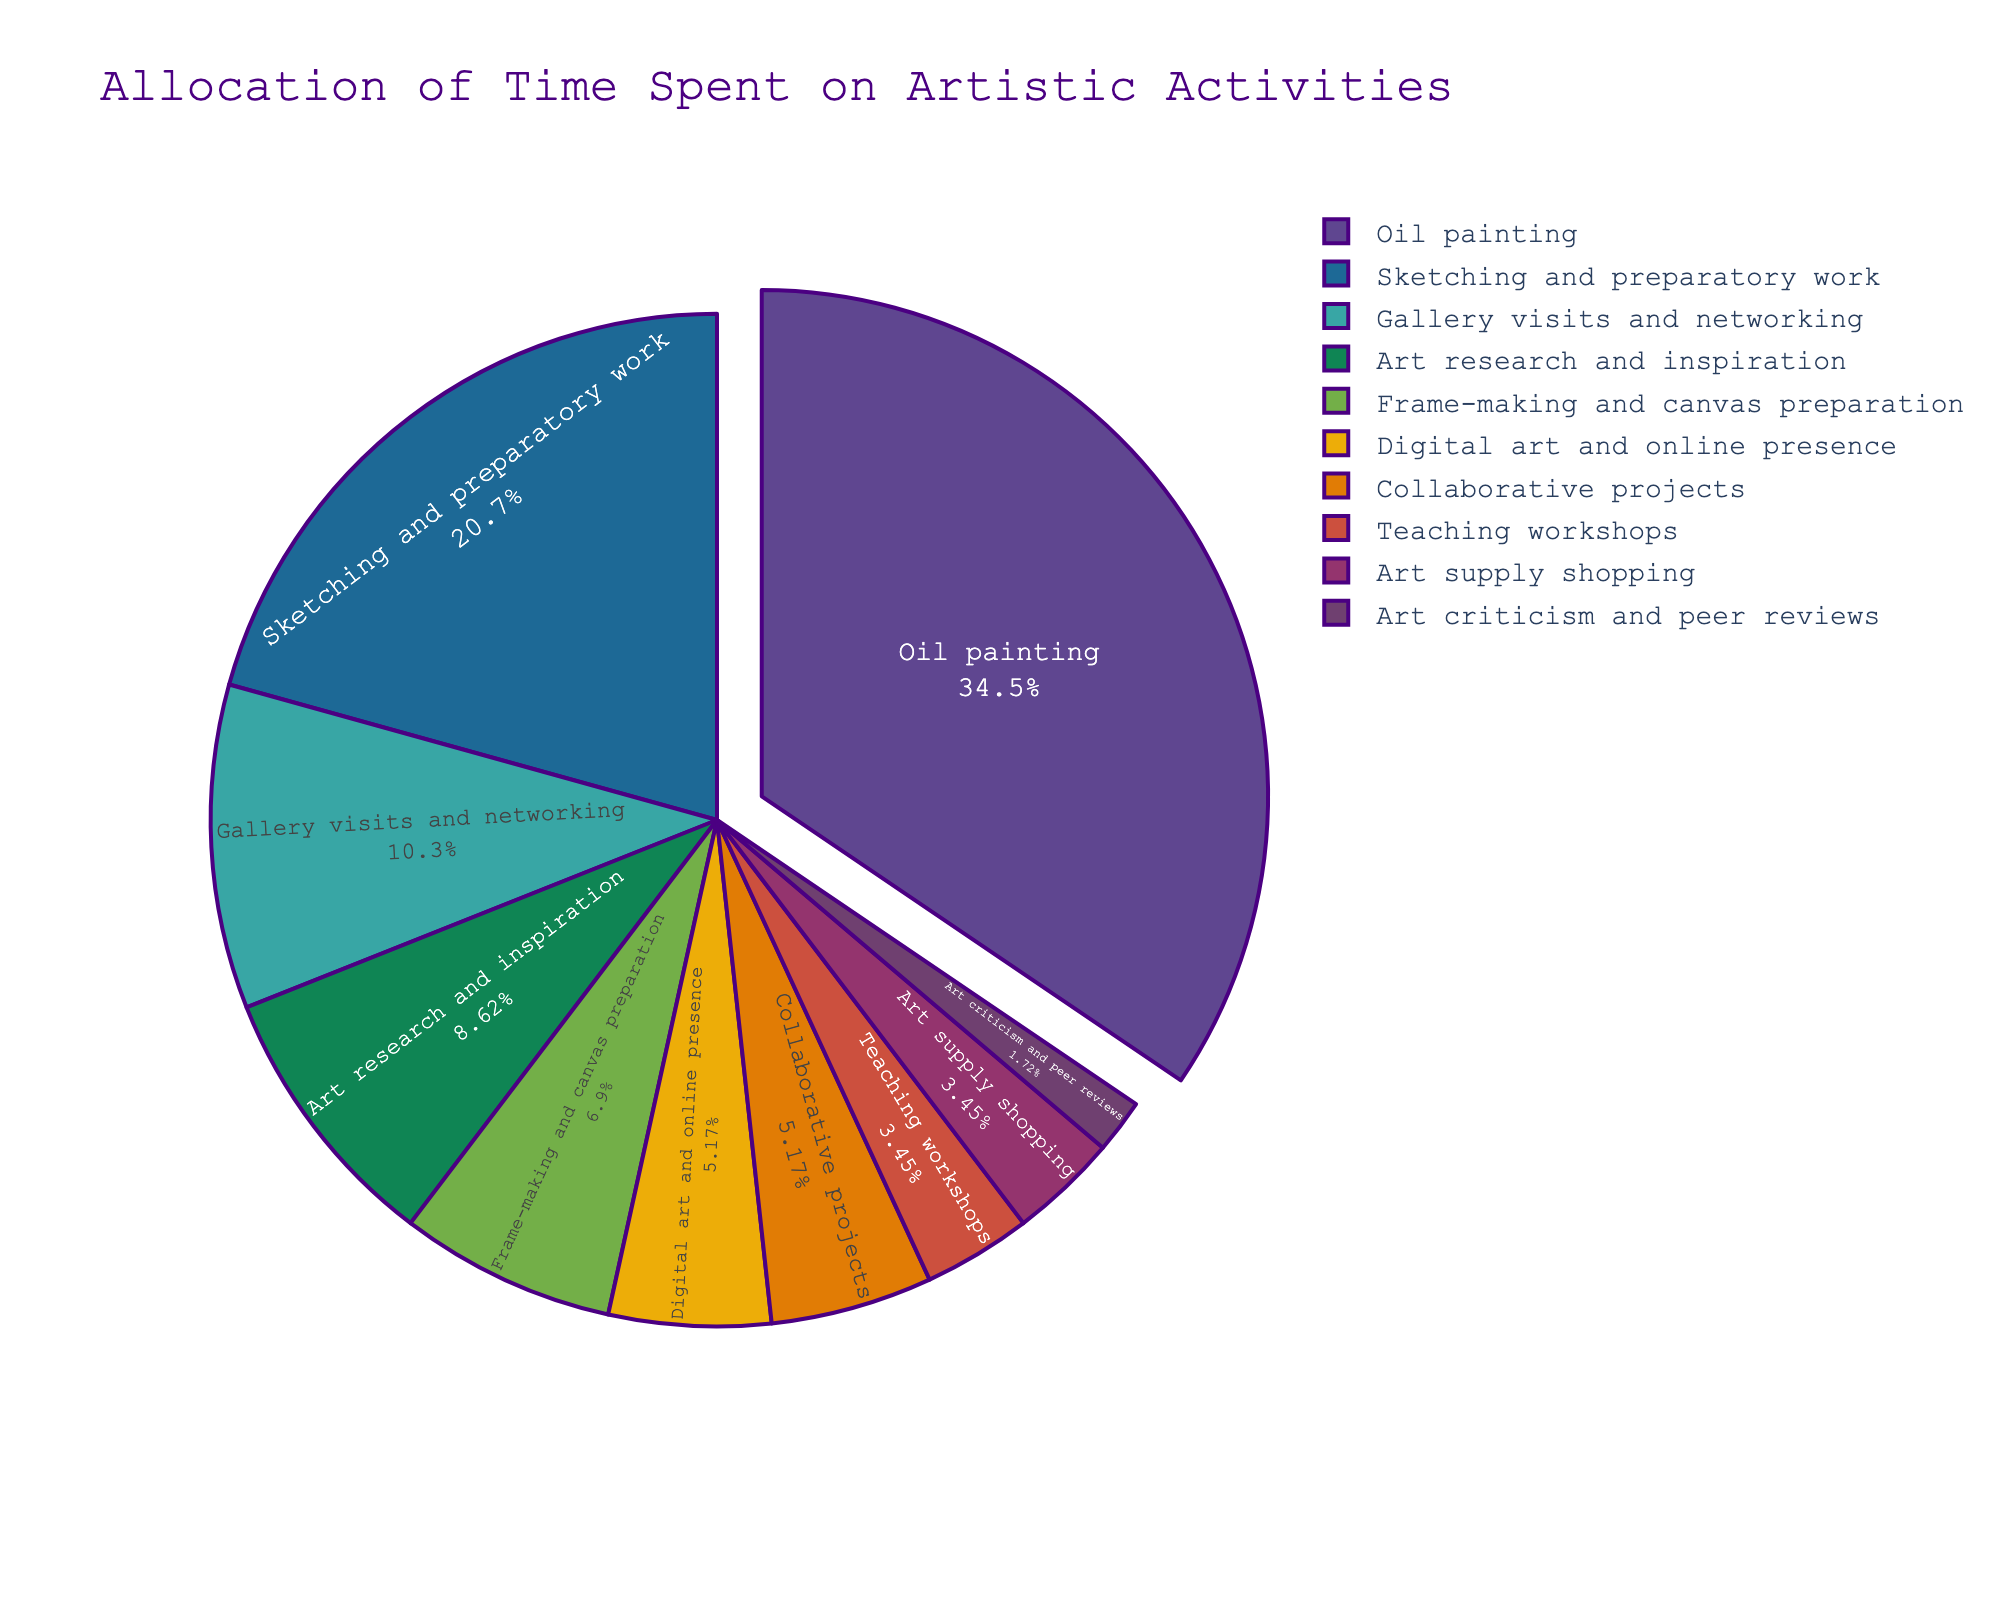What activity takes up the largest percentage of time? The pie chart illustrates that 'Oil painting' occupies the largest section, and it is highlighted by being pulled out slightly from the pie. This visual emphasis indicates it’s the activity with the most hours per week.
Answer: Oil painting Which activities combined take up more than half of the total time spent? From the chart, 'Oil painting' takes up a significant portion on its own, and combined with 'Sketching and preparatory work,' they cover more than half of the total. Summing their percentages visually confirms this.
Answer: Oil painting and Sketching and preparatory work What's the difference in hours spent between 'Sketching and preparatory work' and 'Gallery visits and networking'? From the chart, 'Sketching and preparatory work' takes up 12 hours per week while 'Gallery visits and networking' takes 6 hours. Subtracting these values gives us 12 - 6 = 6.
Answer: 6 hours How many activities take up 3 or fewer hours per week? Visually inspecting the pie chart shows that the activities 'Digital art and online presence,' 'Collaborative projects,' 'Teaching workshops,' 'Art supply shopping,' and 'Art criticism and peer reviews' each take 3 or fewer hours per week. Counting these segments gives a total of 5 activities.
Answer: 5 activities What is the combined percentage of time spent on 'Digital art and online presence' and 'Collaborative projects'? The pie chart labels 'Digital art and online presence' and 'Collaborative projects' as each accounting for approximately the same small-sized sections. Adding their percentages, which are close to 3% and 3%, gives us about 6%.
Answer: 6% Which activity is allocated the least amount of time? The smallest section on the chart is for 'Art criticism and peer reviews,' indicating it has the least hours per week allocated.
Answer: Art criticism and peer reviews How does the time spent on 'Teaching workshops' compare to 'Frame-making and canvas preparation'? 'Frame-making and canvas preparation' takes 4 hours per week while 'Teaching workshops' takes 2 hours per week according to their pie chart slices. Thus, 'Frame-making and canvas preparation' involves more time than 'Teaching workshops.'
Answer: More What is the ratio of time spent on 'Oil painting' to 'Art research and inspiration'? From the chart, 'Oil painting' is 20 hours per week, and 'Art research and inspiration' is 5 hours per week. The ratio can be calculated as 20:5, which simplifies to 4:1.
Answer: 4:1 What's the total time spent on 'Gallery visits and networking' and 'Art research and inspiration' together? The pie chart shows 'Gallery visits and networking' as 6 hours per week and 'Art research and inspiration' as 5 hours. Summing these hours gives us 6 + 5 = 11.
Answer: 11 hours 